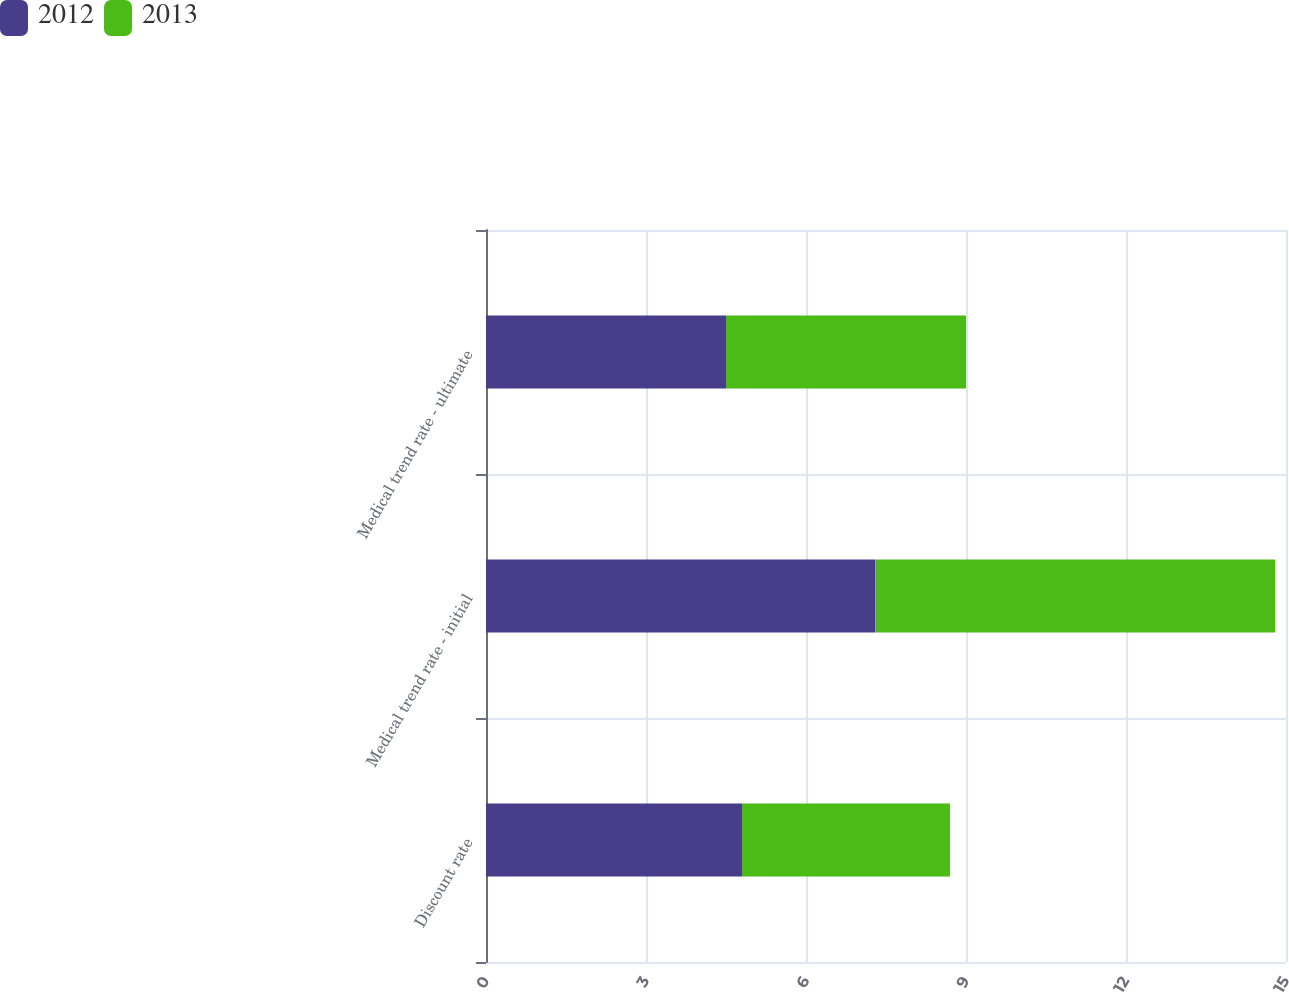Convert chart. <chart><loc_0><loc_0><loc_500><loc_500><stacked_bar_chart><ecel><fcel>Discount rate<fcel>Medical trend rate - initial<fcel>Medical trend rate - ultimate<nl><fcel>2012<fcel>4.8<fcel>7.3<fcel>4.5<nl><fcel>2013<fcel>3.9<fcel>7.5<fcel>4.5<nl></chart> 